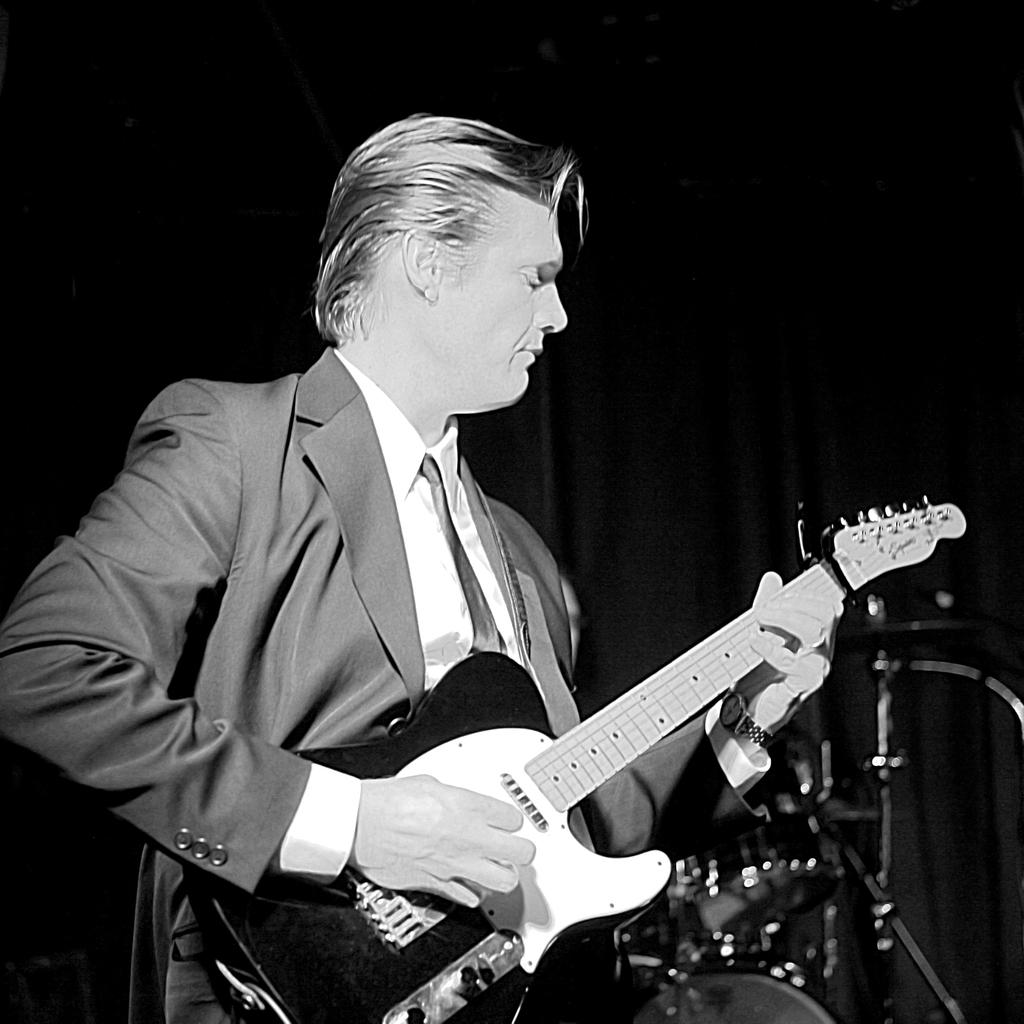What is the main subject of the image? There is a man in the image. What is the man holding in the image? The man is holding a guitar. What type of grain is being cooked on the stove in the image? There is no stove or grain present in the image; it features a man holding a guitar. What expertise does the man have in the image? The image does not provide any information about the man's expertise or skills. 